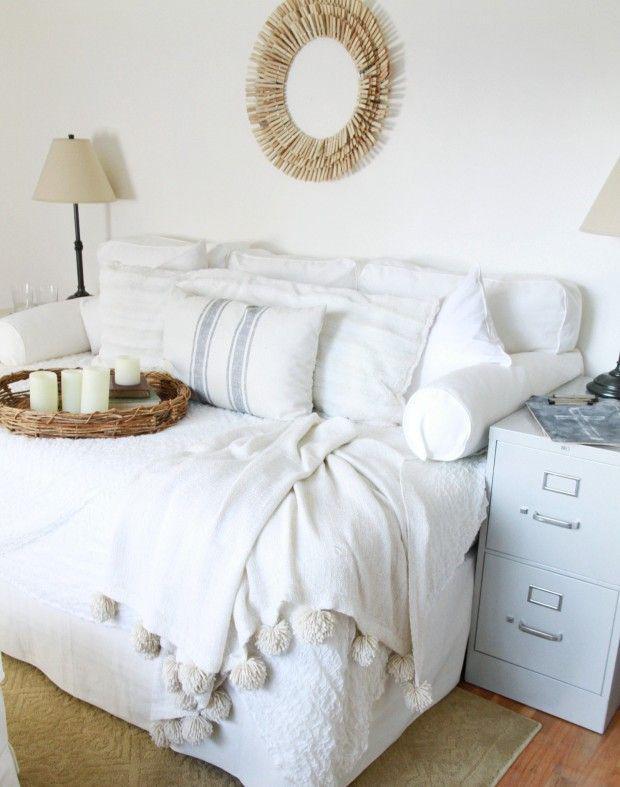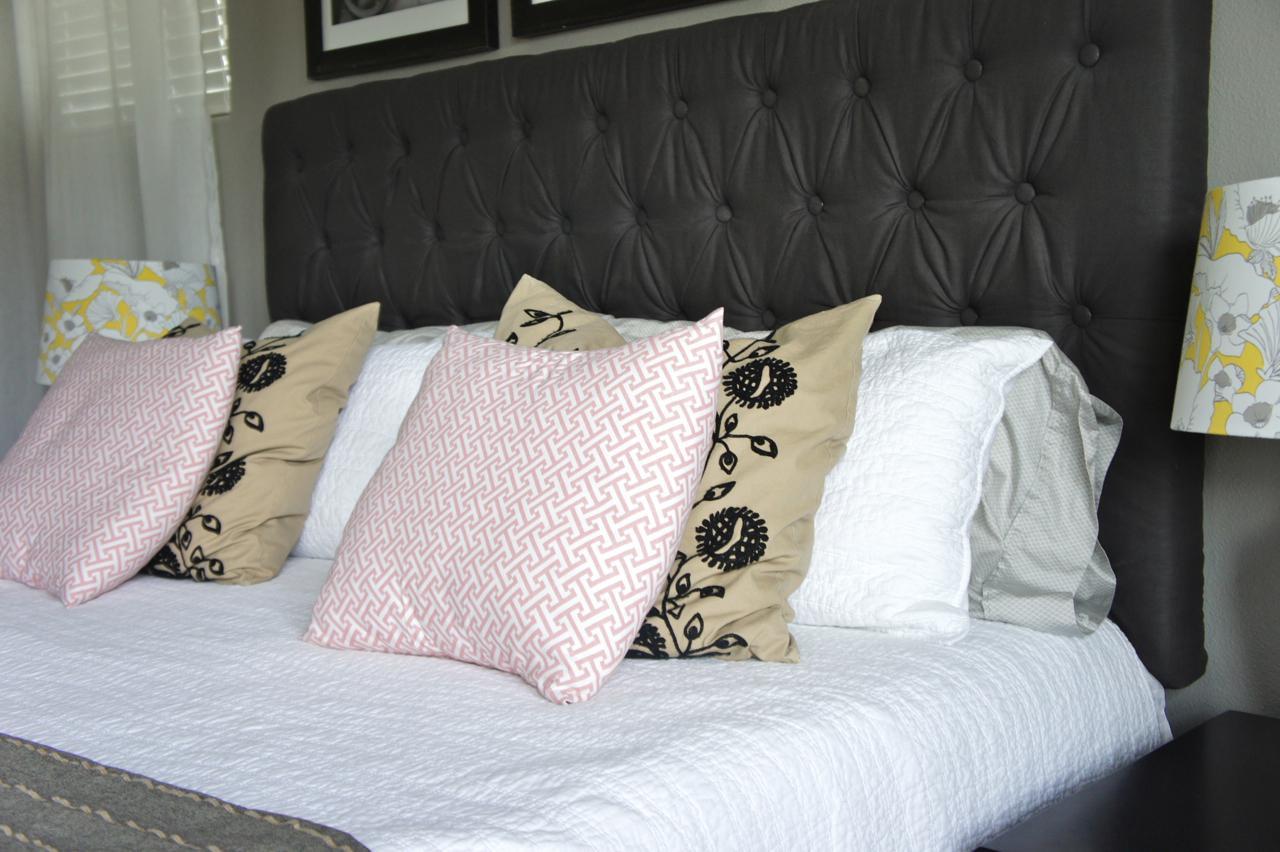The first image is the image on the left, the second image is the image on the right. Examine the images to the left and right. Is the description "On the wall above the headboard of one bed is a round decorative object." accurate? Answer yes or no. Yes. 